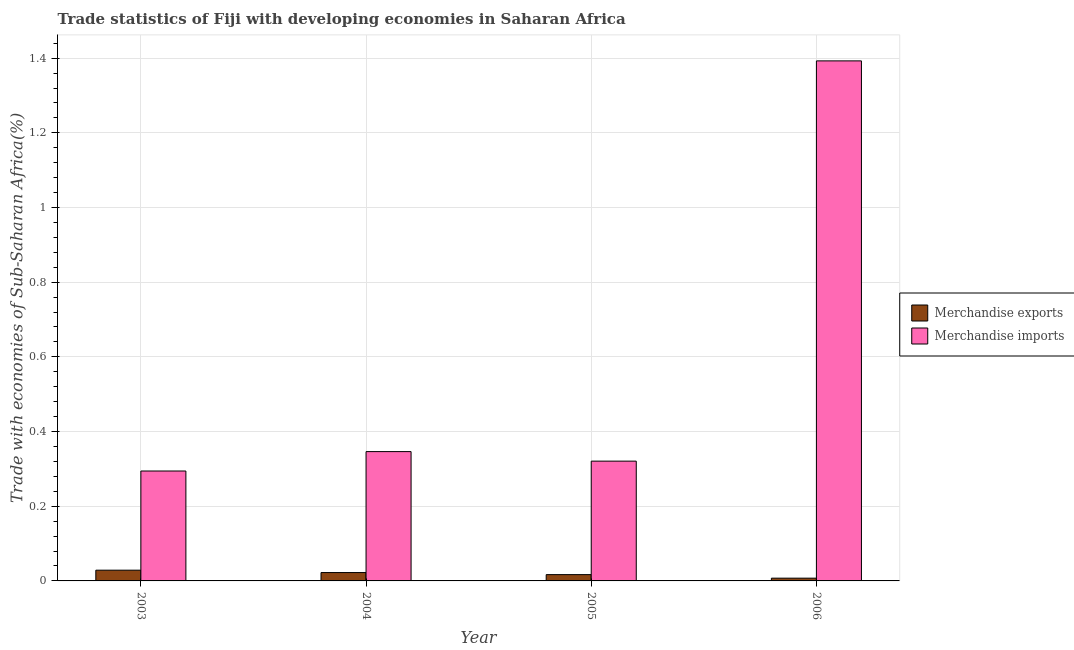Are the number of bars per tick equal to the number of legend labels?
Provide a short and direct response. Yes. Are the number of bars on each tick of the X-axis equal?
Provide a short and direct response. Yes. How many bars are there on the 4th tick from the right?
Your answer should be compact. 2. In how many cases, is the number of bars for a given year not equal to the number of legend labels?
Give a very brief answer. 0. What is the merchandise imports in 2003?
Provide a short and direct response. 0.29. Across all years, what is the maximum merchandise imports?
Provide a short and direct response. 1.39. Across all years, what is the minimum merchandise imports?
Your answer should be very brief. 0.29. What is the total merchandise exports in the graph?
Your response must be concise. 0.08. What is the difference between the merchandise imports in 2004 and that in 2005?
Give a very brief answer. 0.03. What is the difference between the merchandise imports in 2005 and the merchandise exports in 2004?
Provide a succinct answer. -0.03. What is the average merchandise exports per year?
Provide a short and direct response. 0.02. What is the ratio of the merchandise exports in 2003 to that in 2005?
Make the answer very short. 1.71. Is the difference between the merchandise imports in 2003 and 2004 greater than the difference between the merchandise exports in 2003 and 2004?
Provide a short and direct response. No. What is the difference between the highest and the second highest merchandise exports?
Your answer should be very brief. 0.01. What is the difference between the highest and the lowest merchandise imports?
Provide a short and direct response. 1.1. Is the sum of the merchandise exports in 2003 and 2005 greater than the maximum merchandise imports across all years?
Your answer should be very brief. Yes. What does the 1st bar from the right in 2006 represents?
Your response must be concise. Merchandise imports. Are all the bars in the graph horizontal?
Your answer should be very brief. No. How many years are there in the graph?
Offer a very short reply. 4. Where does the legend appear in the graph?
Provide a short and direct response. Center right. How many legend labels are there?
Offer a very short reply. 2. What is the title of the graph?
Your response must be concise. Trade statistics of Fiji with developing economies in Saharan Africa. Does "Not attending school" appear as one of the legend labels in the graph?
Offer a terse response. No. What is the label or title of the X-axis?
Keep it short and to the point. Year. What is the label or title of the Y-axis?
Ensure brevity in your answer.  Trade with economies of Sub-Saharan Africa(%). What is the Trade with economies of Sub-Saharan Africa(%) of Merchandise exports in 2003?
Provide a short and direct response. 0.03. What is the Trade with economies of Sub-Saharan Africa(%) of Merchandise imports in 2003?
Your answer should be compact. 0.29. What is the Trade with economies of Sub-Saharan Africa(%) in Merchandise exports in 2004?
Give a very brief answer. 0.02. What is the Trade with economies of Sub-Saharan Africa(%) of Merchandise imports in 2004?
Keep it short and to the point. 0.35. What is the Trade with economies of Sub-Saharan Africa(%) in Merchandise exports in 2005?
Your response must be concise. 0.02. What is the Trade with economies of Sub-Saharan Africa(%) in Merchandise imports in 2005?
Keep it short and to the point. 0.32. What is the Trade with economies of Sub-Saharan Africa(%) in Merchandise exports in 2006?
Keep it short and to the point. 0.01. What is the Trade with economies of Sub-Saharan Africa(%) in Merchandise imports in 2006?
Keep it short and to the point. 1.39. Across all years, what is the maximum Trade with economies of Sub-Saharan Africa(%) of Merchandise exports?
Offer a terse response. 0.03. Across all years, what is the maximum Trade with economies of Sub-Saharan Africa(%) in Merchandise imports?
Your answer should be compact. 1.39. Across all years, what is the minimum Trade with economies of Sub-Saharan Africa(%) of Merchandise exports?
Provide a succinct answer. 0.01. Across all years, what is the minimum Trade with economies of Sub-Saharan Africa(%) in Merchandise imports?
Give a very brief answer. 0.29. What is the total Trade with economies of Sub-Saharan Africa(%) in Merchandise exports in the graph?
Ensure brevity in your answer.  0.08. What is the total Trade with economies of Sub-Saharan Africa(%) in Merchandise imports in the graph?
Provide a succinct answer. 2.35. What is the difference between the Trade with economies of Sub-Saharan Africa(%) in Merchandise exports in 2003 and that in 2004?
Provide a short and direct response. 0.01. What is the difference between the Trade with economies of Sub-Saharan Africa(%) of Merchandise imports in 2003 and that in 2004?
Provide a succinct answer. -0.05. What is the difference between the Trade with economies of Sub-Saharan Africa(%) in Merchandise exports in 2003 and that in 2005?
Offer a very short reply. 0.01. What is the difference between the Trade with economies of Sub-Saharan Africa(%) of Merchandise imports in 2003 and that in 2005?
Keep it short and to the point. -0.03. What is the difference between the Trade with economies of Sub-Saharan Africa(%) of Merchandise exports in 2003 and that in 2006?
Provide a succinct answer. 0.02. What is the difference between the Trade with economies of Sub-Saharan Africa(%) in Merchandise imports in 2003 and that in 2006?
Provide a short and direct response. -1.1. What is the difference between the Trade with economies of Sub-Saharan Africa(%) in Merchandise exports in 2004 and that in 2005?
Give a very brief answer. 0.01. What is the difference between the Trade with economies of Sub-Saharan Africa(%) in Merchandise imports in 2004 and that in 2005?
Your answer should be compact. 0.03. What is the difference between the Trade with economies of Sub-Saharan Africa(%) in Merchandise exports in 2004 and that in 2006?
Make the answer very short. 0.01. What is the difference between the Trade with economies of Sub-Saharan Africa(%) in Merchandise imports in 2004 and that in 2006?
Give a very brief answer. -1.05. What is the difference between the Trade with economies of Sub-Saharan Africa(%) of Merchandise exports in 2005 and that in 2006?
Give a very brief answer. 0.01. What is the difference between the Trade with economies of Sub-Saharan Africa(%) of Merchandise imports in 2005 and that in 2006?
Offer a very short reply. -1.07. What is the difference between the Trade with economies of Sub-Saharan Africa(%) of Merchandise exports in 2003 and the Trade with economies of Sub-Saharan Africa(%) of Merchandise imports in 2004?
Your answer should be very brief. -0.32. What is the difference between the Trade with economies of Sub-Saharan Africa(%) of Merchandise exports in 2003 and the Trade with economies of Sub-Saharan Africa(%) of Merchandise imports in 2005?
Make the answer very short. -0.29. What is the difference between the Trade with economies of Sub-Saharan Africa(%) in Merchandise exports in 2003 and the Trade with economies of Sub-Saharan Africa(%) in Merchandise imports in 2006?
Make the answer very short. -1.36. What is the difference between the Trade with economies of Sub-Saharan Africa(%) of Merchandise exports in 2004 and the Trade with economies of Sub-Saharan Africa(%) of Merchandise imports in 2005?
Offer a very short reply. -0.3. What is the difference between the Trade with economies of Sub-Saharan Africa(%) in Merchandise exports in 2004 and the Trade with economies of Sub-Saharan Africa(%) in Merchandise imports in 2006?
Offer a very short reply. -1.37. What is the difference between the Trade with economies of Sub-Saharan Africa(%) of Merchandise exports in 2005 and the Trade with economies of Sub-Saharan Africa(%) of Merchandise imports in 2006?
Ensure brevity in your answer.  -1.38. What is the average Trade with economies of Sub-Saharan Africa(%) of Merchandise exports per year?
Ensure brevity in your answer.  0.02. What is the average Trade with economies of Sub-Saharan Africa(%) of Merchandise imports per year?
Provide a succinct answer. 0.59. In the year 2003, what is the difference between the Trade with economies of Sub-Saharan Africa(%) in Merchandise exports and Trade with economies of Sub-Saharan Africa(%) in Merchandise imports?
Give a very brief answer. -0.27. In the year 2004, what is the difference between the Trade with economies of Sub-Saharan Africa(%) in Merchandise exports and Trade with economies of Sub-Saharan Africa(%) in Merchandise imports?
Offer a terse response. -0.32. In the year 2005, what is the difference between the Trade with economies of Sub-Saharan Africa(%) of Merchandise exports and Trade with economies of Sub-Saharan Africa(%) of Merchandise imports?
Keep it short and to the point. -0.3. In the year 2006, what is the difference between the Trade with economies of Sub-Saharan Africa(%) of Merchandise exports and Trade with economies of Sub-Saharan Africa(%) of Merchandise imports?
Offer a very short reply. -1.39. What is the ratio of the Trade with economies of Sub-Saharan Africa(%) in Merchandise exports in 2003 to that in 2004?
Ensure brevity in your answer.  1.28. What is the ratio of the Trade with economies of Sub-Saharan Africa(%) of Merchandise imports in 2003 to that in 2004?
Provide a succinct answer. 0.85. What is the ratio of the Trade with economies of Sub-Saharan Africa(%) of Merchandise exports in 2003 to that in 2005?
Keep it short and to the point. 1.71. What is the ratio of the Trade with economies of Sub-Saharan Africa(%) of Merchandise imports in 2003 to that in 2005?
Keep it short and to the point. 0.92. What is the ratio of the Trade with economies of Sub-Saharan Africa(%) in Merchandise exports in 2003 to that in 2006?
Your response must be concise. 3.89. What is the ratio of the Trade with economies of Sub-Saharan Africa(%) in Merchandise imports in 2003 to that in 2006?
Ensure brevity in your answer.  0.21. What is the ratio of the Trade with economies of Sub-Saharan Africa(%) in Merchandise exports in 2004 to that in 2005?
Provide a succinct answer. 1.33. What is the ratio of the Trade with economies of Sub-Saharan Africa(%) in Merchandise imports in 2004 to that in 2005?
Provide a short and direct response. 1.08. What is the ratio of the Trade with economies of Sub-Saharan Africa(%) of Merchandise exports in 2004 to that in 2006?
Provide a succinct answer. 3.03. What is the ratio of the Trade with economies of Sub-Saharan Africa(%) of Merchandise imports in 2004 to that in 2006?
Provide a succinct answer. 0.25. What is the ratio of the Trade with economies of Sub-Saharan Africa(%) in Merchandise exports in 2005 to that in 2006?
Keep it short and to the point. 2.28. What is the ratio of the Trade with economies of Sub-Saharan Africa(%) in Merchandise imports in 2005 to that in 2006?
Your response must be concise. 0.23. What is the difference between the highest and the second highest Trade with economies of Sub-Saharan Africa(%) of Merchandise exports?
Offer a very short reply. 0.01. What is the difference between the highest and the second highest Trade with economies of Sub-Saharan Africa(%) in Merchandise imports?
Make the answer very short. 1.05. What is the difference between the highest and the lowest Trade with economies of Sub-Saharan Africa(%) in Merchandise exports?
Offer a very short reply. 0.02. What is the difference between the highest and the lowest Trade with economies of Sub-Saharan Africa(%) of Merchandise imports?
Your answer should be very brief. 1.1. 